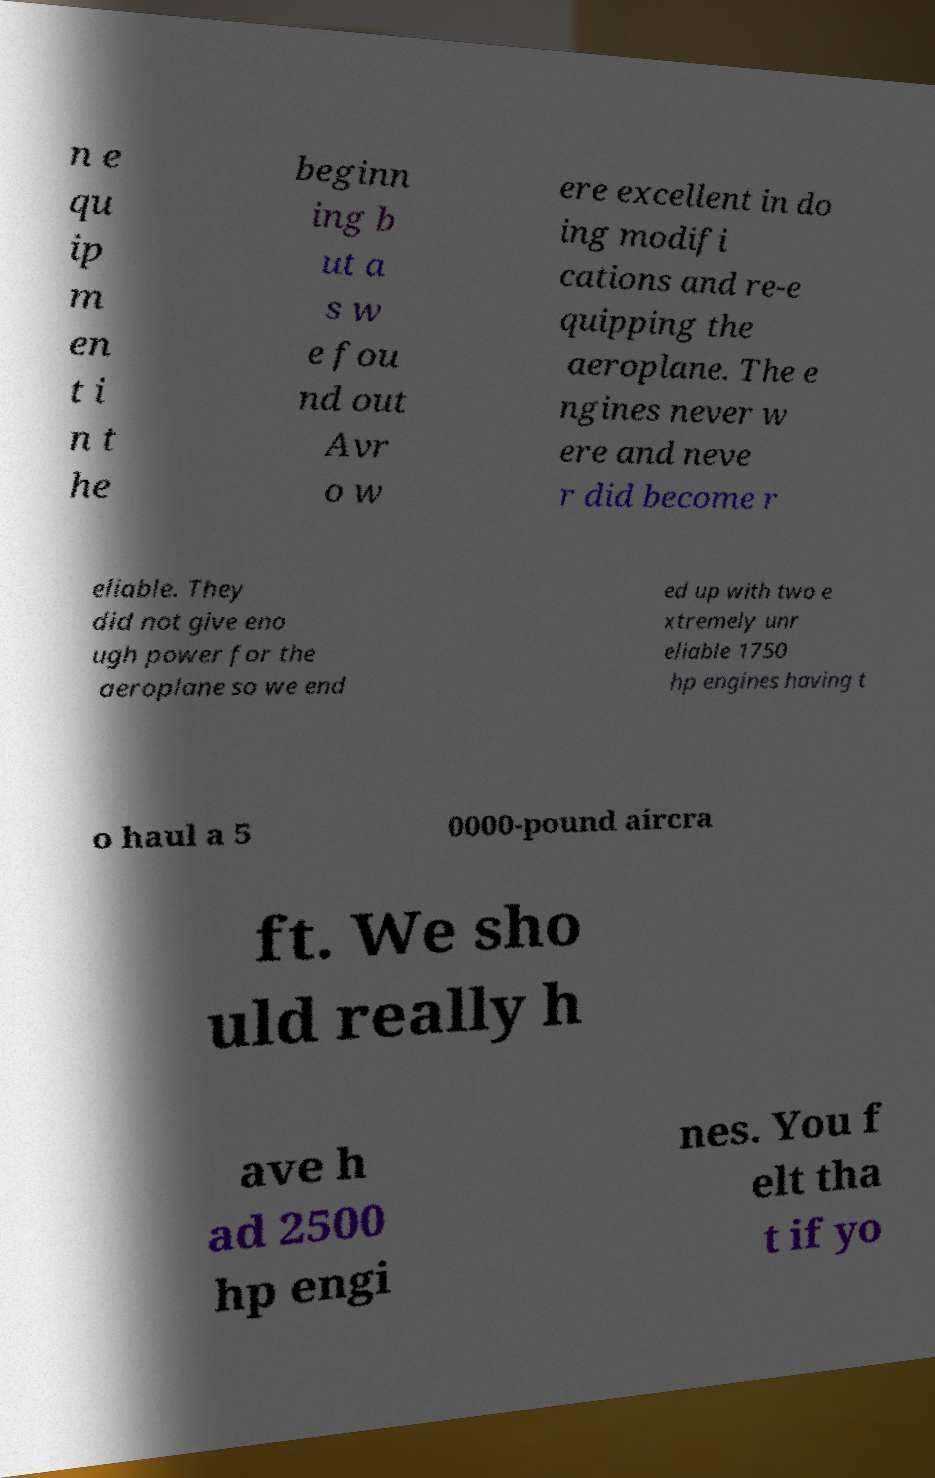What messages or text are displayed in this image? I need them in a readable, typed format. n e qu ip m en t i n t he beginn ing b ut a s w e fou nd out Avr o w ere excellent in do ing modifi cations and re-e quipping the aeroplane. The e ngines never w ere and neve r did become r eliable. They did not give eno ugh power for the aeroplane so we end ed up with two e xtremely unr eliable 1750 hp engines having t o haul a 5 0000-pound aircra ft. We sho uld really h ave h ad 2500 hp engi nes. You f elt tha t if yo 